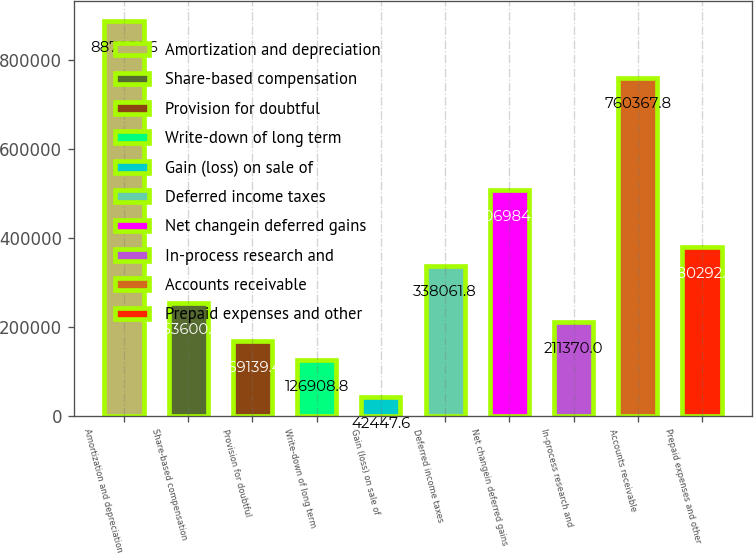<chart> <loc_0><loc_0><loc_500><loc_500><bar_chart><fcel>Amortization and depreciation<fcel>Share-based compensation<fcel>Provision for doubtful<fcel>Write-down of long term<fcel>Gain (loss) on sale of<fcel>Deferred income taxes<fcel>Net changein deferred gains<fcel>In-process research and<fcel>Accounts receivable<fcel>Prepaid expenses and other<nl><fcel>887060<fcel>253601<fcel>169139<fcel>126909<fcel>42447.6<fcel>338062<fcel>506984<fcel>211370<fcel>760368<fcel>380292<nl></chart> 